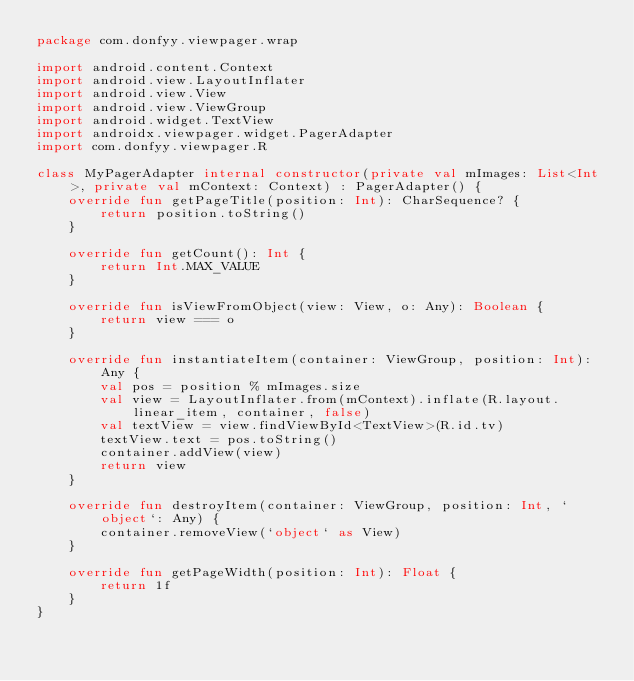Convert code to text. <code><loc_0><loc_0><loc_500><loc_500><_Kotlin_>package com.donfyy.viewpager.wrap

import android.content.Context
import android.view.LayoutInflater
import android.view.View
import android.view.ViewGroup
import android.widget.TextView
import androidx.viewpager.widget.PagerAdapter
import com.donfyy.viewpager.R

class MyPagerAdapter internal constructor(private val mImages: List<Int>, private val mContext: Context) : PagerAdapter() {
    override fun getPageTitle(position: Int): CharSequence? {
        return position.toString()
    }

    override fun getCount(): Int {
        return Int.MAX_VALUE
    }

    override fun isViewFromObject(view: View, o: Any): Boolean {
        return view === o
    }

    override fun instantiateItem(container: ViewGroup, position: Int): Any {
        val pos = position % mImages.size
        val view = LayoutInflater.from(mContext).inflate(R.layout.linear_item, container, false)
        val textView = view.findViewById<TextView>(R.id.tv)
        textView.text = pos.toString()
        container.addView(view)
        return view
    }

    override fun destroyItem(container: ViewGroup, position: Int, `object`: Any) {
        container.removeView(`object` as View)
    }

    override fun getPageWidth(position: Int): Float {
        return 1f
    }
}</code> 